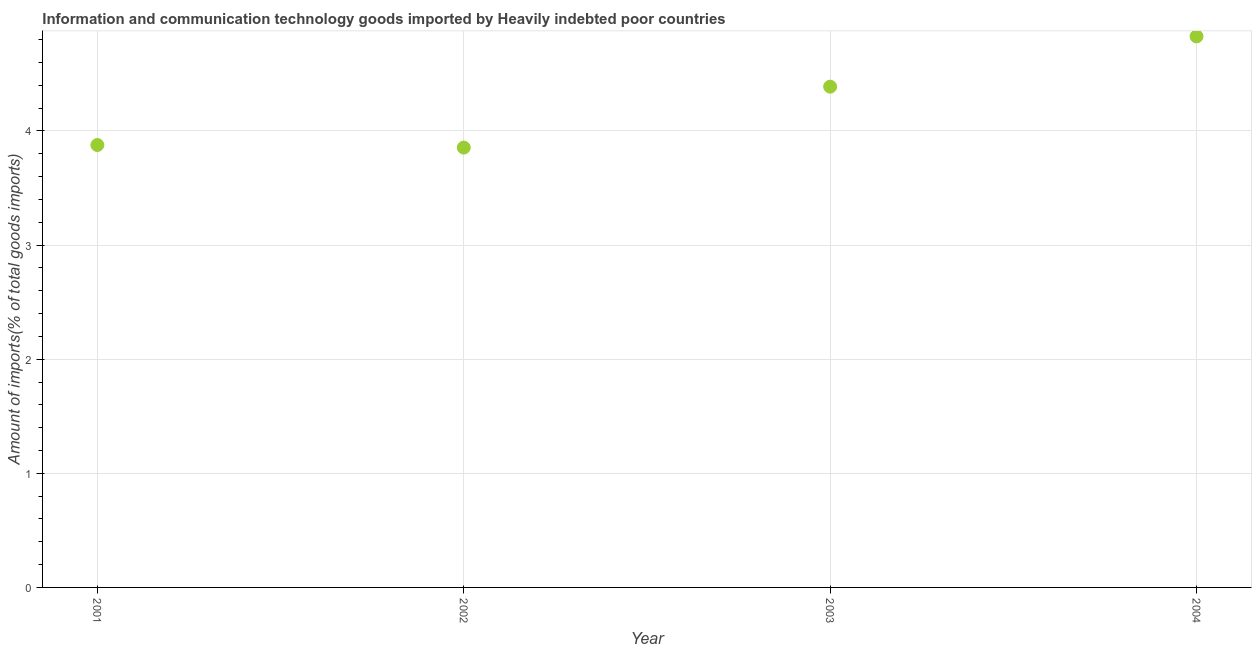What is the amount of ict goods imports in 2003?
Give a very brief answer. 4.39. Across all years, what is the maximum amount of ict goods imports?
Ensure brevity in your answer.  4.83. Across all years, what is the minimum amount of ict goods imports?
Provide a short and direct response. 3.85. In which year was the amount of ict goods imports maximum?
Your response must be concise. 2004. What is the sum of the amount of ict goods imports?
Your answer should be compact. 16.95. What is the difference between the amount of ict goods imports in 2003 and 2004?
Give a very brief answer. -0.44. What is the average amount of ict goods imports per year?
Your answer should be very brief. 4.24. What is the median amount of ict goods imports?
Your answer should be very brief. 4.13. Do a majority of the years between 2004 and 2002 (inclusive) have amount of ict goods imports greater than 0.8 %?
Provide a succinct answer. No. What is the ratio of the amount of ict goods imports in 2001 to that in 2002?
Keep it short and to the point. 1.01. Is the difference between the amount of ict goods imports in 2002 and 2003 greater than the difference between any two years?
Give a very brief answer. No. What is the difference between the highest and the second highest amount of ict goods imports?
Offer a very short reply. 0.44. Is the sum of the amount of ict goods imports in 2001 and 2004 greater than the maximum amount of ict goods imports across all years?
Your answer should be compact. Yes. What is the difference between the highest and the lowest amount of ict goods imports?
Your answer should be compact. 0.97. How many dotlines are there?
Provide a succinct answer. 1. Are the values on the major ticks of Y-axis written in scientific E-notation?
Make the answer very short. No. Does the graph contain any zero values?
Make the answer very short. No. Does the graph contain grids?
Your response must be concise. Yes. What is the title of the graph?
Your answer should be very brief. Information and communication technology goods imported by Heavily indebted poor countries. What is the label or title of the Y-axis?
Provide a short and direct response. Amount of imports(% of total goods imports). What is the Amount of imports(% of total goods imports) in 2001?
Provide a short and direct response. 3.88. What is the Amount of imports(% of total goods imports) in 2002?
Provide a short and direct response. 3.85. What is the Amount of imports(% of total goods imports) in 2003?
Keep it short and to the point. 4.39. What is the Amount of imports(% of total goods imports) in 2004?
Your response must be concise. 4.83. What is the difference between the Amount of imports(% of total goods imports) in 2001 and 2002?
Provide a short and direct response. 0.02. What is the difference between the Amount of imports(% of total goods imports) in 2001 and 2003?
Your answer should be compact. -0.51. What is the difference between the Amount of imports(% of total goods imports) in 2001 and 2004?
Offer a very short reply. -0.95. What is the difference between the Amount of imports(% of total goods imports) in 2002 and 2003?
Provide a short and direct response. -0.53. What is the difference between the Amount of imports(% of total goods imports) in 2002 and 2004?
Your answer should be compact. -0.97. What is the difference between the Amount of imports(% of total goods imports) in 2003 and 2004?
Your answer should be very brief. -0.44. What is the ratio of the Amount of imports(% of total goods imports) in 2001 to that in 2003?
Offer a very short reply. 0.88. What is the ratio of the Amount of imports(% of total goods imports) in 2001 to that in 2004?
Provide a short and direct response. 0.8. What is the ratio of the Amount of imports(% of total goods imports) in 2002 to that in 2003?
Offer a very short reply. 0.88. What is the ratio of the Amount of imports(% of total goods imports) in 2002 to that in 2004?
Make the answer very short. 0.8. What is the ratio of the Amount of imports(% of total goods imports) in 2003 to that in 2004?
Provide a succinct answer. 0.91. 